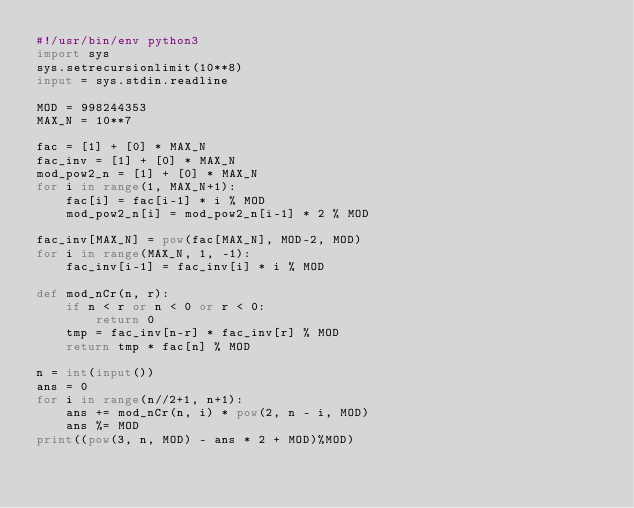<code> <loc_0><loc_0><loc_500><loc_500><_Python_>#!/usr/bin/env python3
import sys
sys.setrecursionlimit(10**8)
input = sys.stdin.readline

MOD = 998244353
MAX_N = 10**7 

fac = [1] + [0] * MAX_N
fac_inv = [1] + [0] * MAX_N
mod_pow2_n = [1] + [0] * MAX_N
for i in range(1, MAX_N+1):
    fac[i] = fac[i-1] * i % MOD
    mod_pow2_n[i] = mod_pow2_n[i-1] * 2 % MOD

fac_inv[MAX_N] = pow(fac[MAX_N], MOD-2, MOD)
for i in range(MAX_N, 1, -1):
    fac_inv[i-1] = fac_inv[i] * i % MOD

def mod_nCr(n, r):
    if n < r or n < 0 or r < 0:
        return 0
    tmp = fac_inv[n-r] * fac_inv[r] % MOD
    return tmp * fac[n] % MOD 
    
n = int(input())
ans = 0
for i in range(n//2+1, n+1):
    ans += mod_nCr(n, i) * pow(2, n - i, MOD)
    ans %= MOD
print((pow(3, n, MOD) - ans * 2 + MOD)%MOD)</code> 